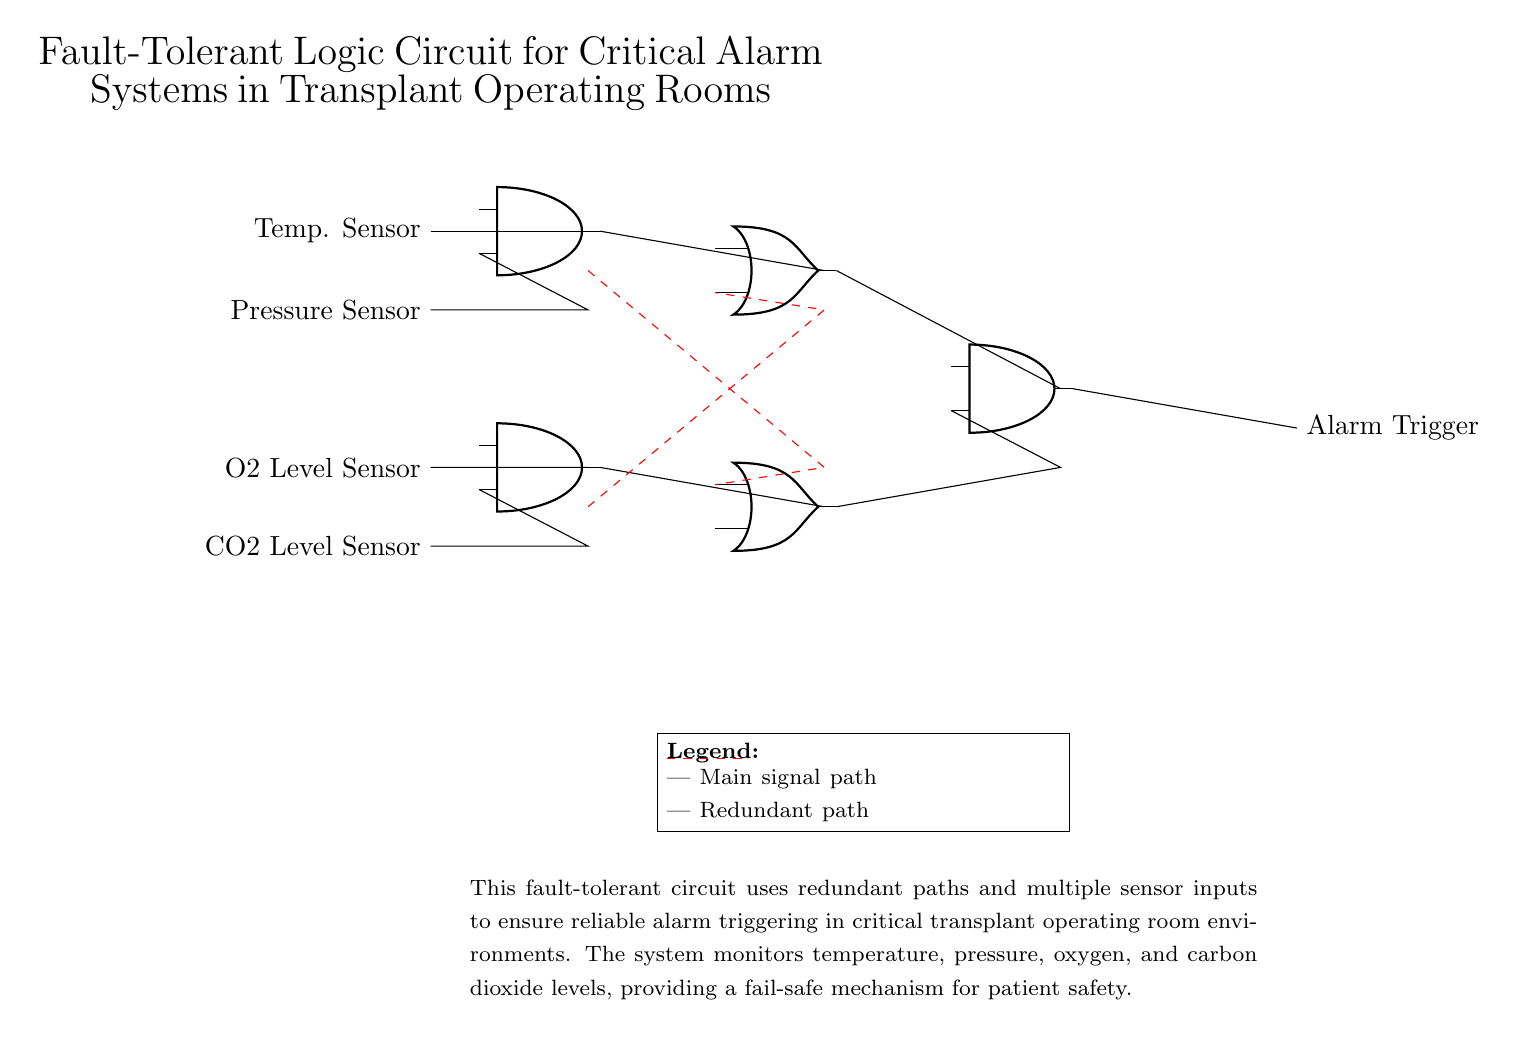What are the two main types of sensors used in this circuit? The circuit includes two types of sensors: temperature sensors and pressure sensors. These sensors provide critical information necessary for the alarm system to function effectively.
Answer: temperature and pressure sensors How many AND gates are present in the circuit? The circuit diagram shows three distinct AND gates, indicated by their respective symbols. Each AND gate processes inputs from different sensors, contributing to the final output.
Answer: three What is the output of this circuit? The alarm trigger is the final output of this logic circuit, which signals when sensor conditions are met. This output is essential for alerting medical staff in critical situations.
Answer: alarm trigger What do the dashed red lines represent? The dashed red lines indicate redundancy paths in the circuit, providing alternate routes for signal flow if primary paths fail. This design enhances the circuit's fault tolerance.
Answer: redundancy paths How many OR gates are included in the circuit? There are two OR gates present in the circuit, as identified by their symbols. They combine the outputs from the AND gates to determine if the alarm should be triggered.
Answer: two Why is fault tolerance necessary in this circuit? Fault tolerance is crucial in medical environments, particularly in transplant operating rooms, to ensure the reliability and safety of alarm systems. It mitigates the risk of failure that could jeopardize patient safety.
Answer: patient safety 